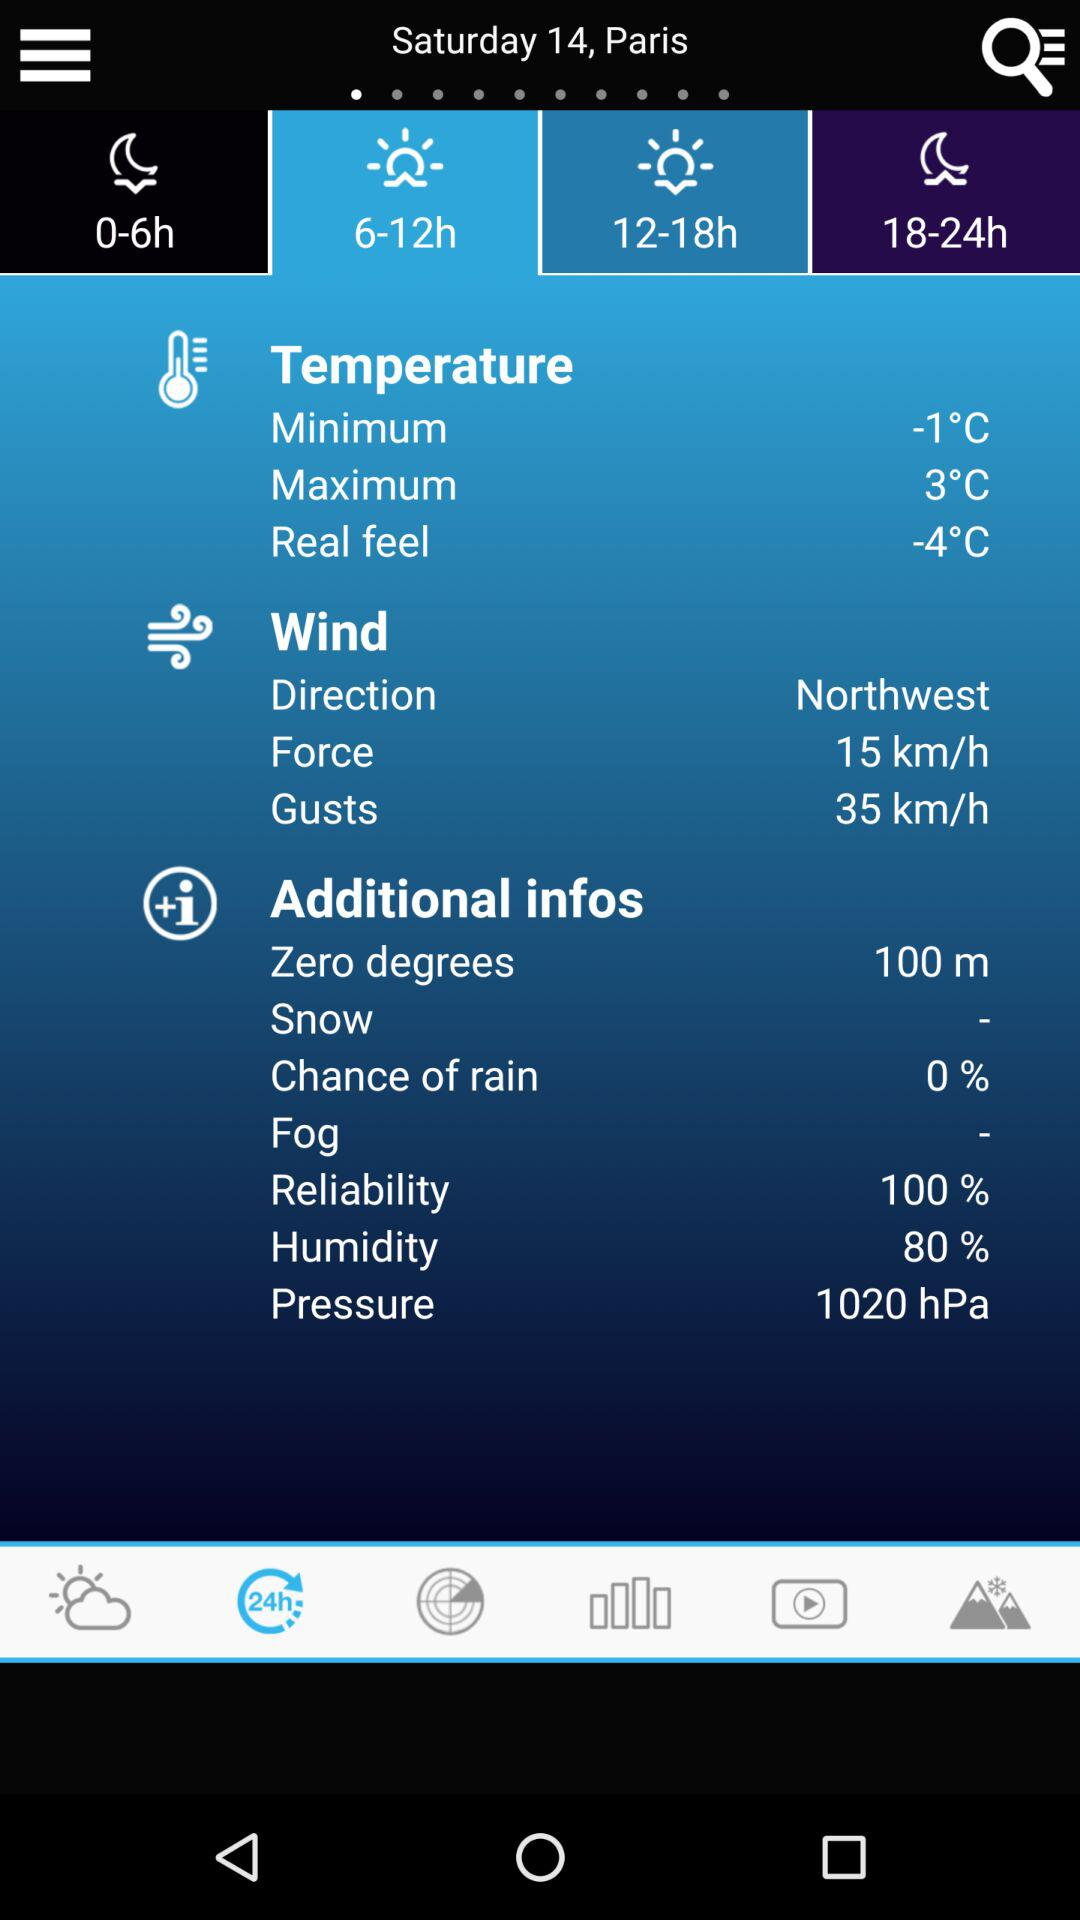What is the humidity percentage? The humidity percentage is 80. 